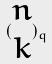Convert formula to latex. <formula><loc_0><loc_0><loc_500><loc_500>( \begin{matrix} n \\ k \end{matrix} ) _ { q }</formula> 